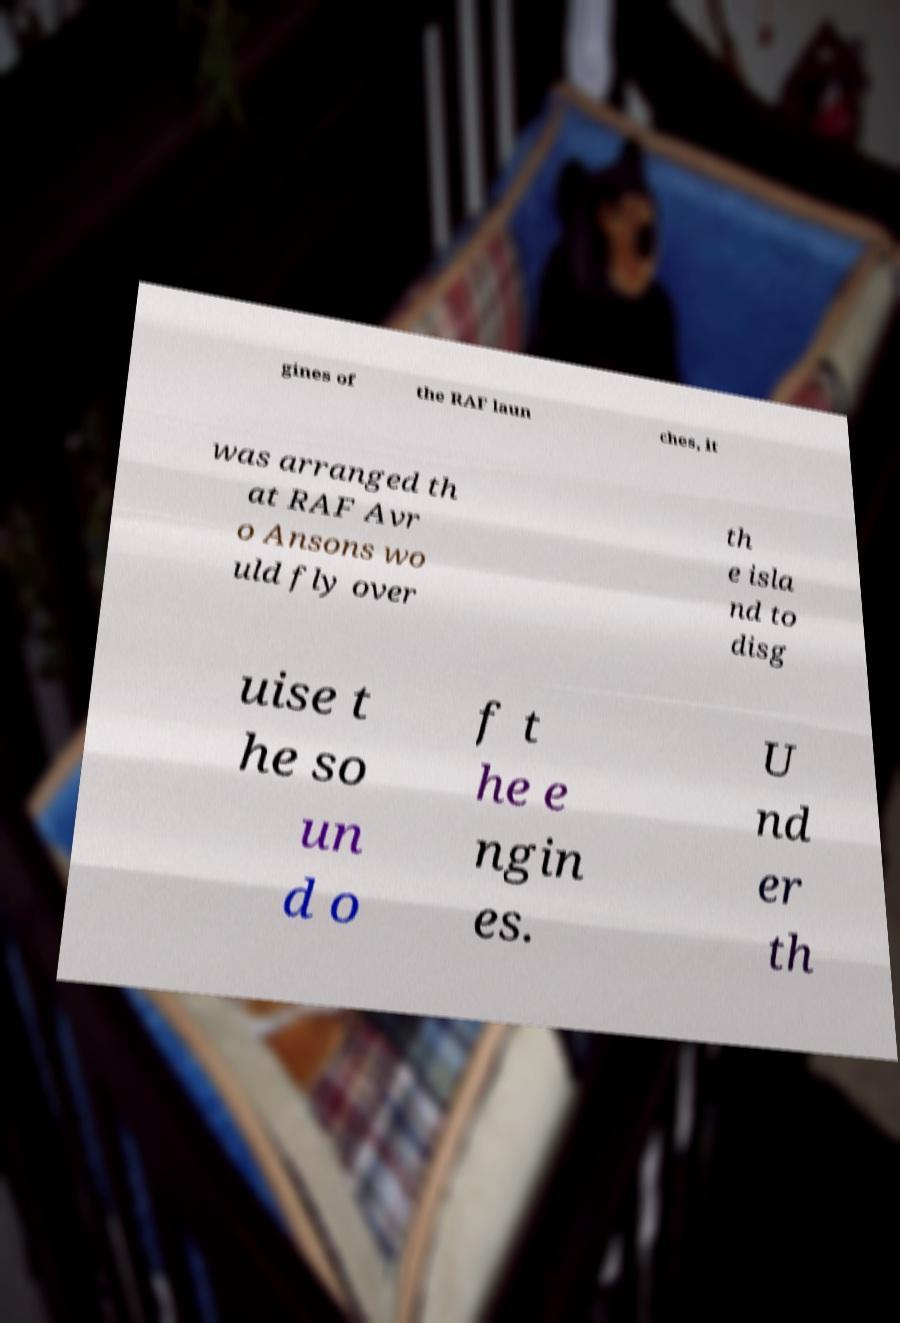Can you read and provide the text displayed in the image?This photo seems to have some interesting text. Can you extract and type it out for me? gines of the RAF laun ches, it was arranged th at RAF Avr o Ansons wo uld fly over th e isla nd to disg uise t he so un d o f t he e ngin es. U nd er th 